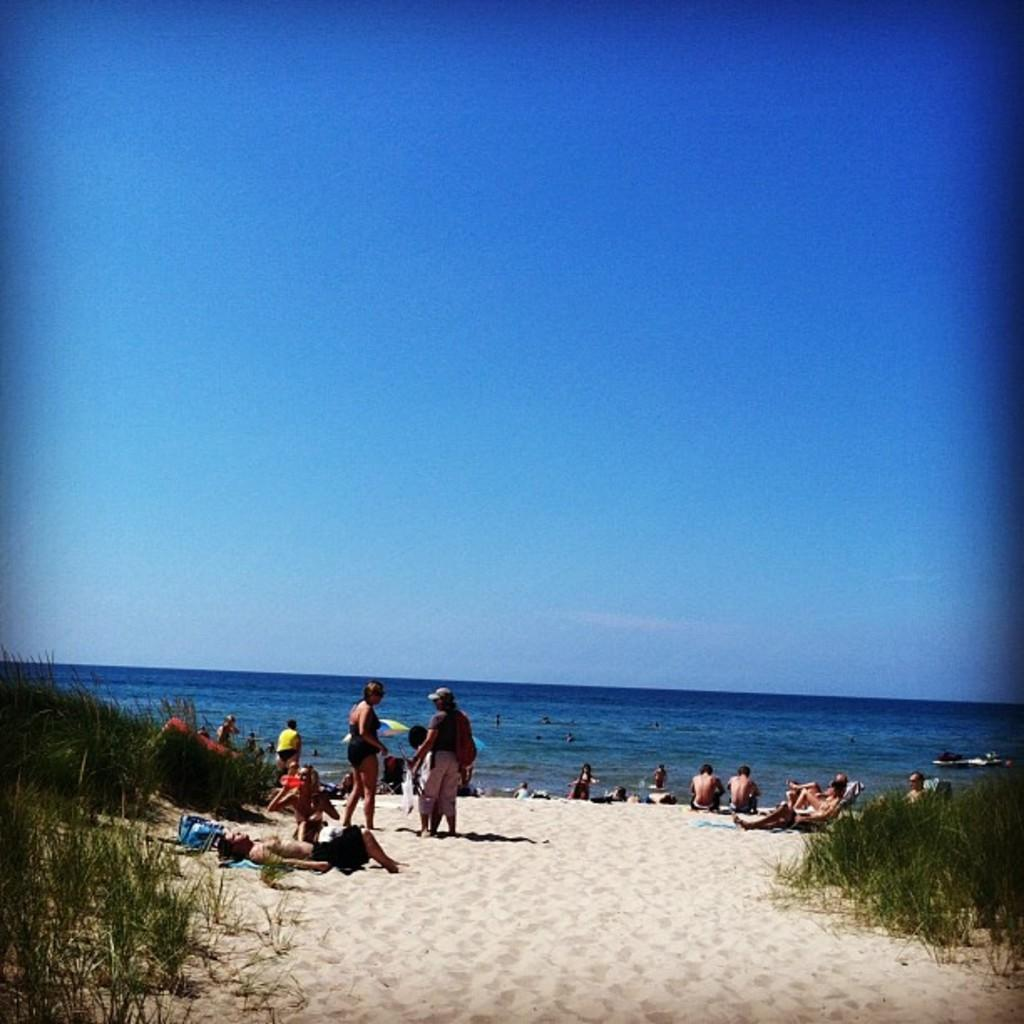What are the people in the image doing? There are people standing, sitting, and laying in the image. Where is the image taken? The location is a beach. What type of vegetation is present at the beach? There is grass on the land. What can be seen in the background of the image? There is an ocean and the sky visible in the background of the image. What is the income of the people playing basketball in the image? There is no basketball or indication of income in the image; it features people at a beach. What order are the people standing in the image? The image does not depict a specific order for the people standing; they are simply standing in various positions. 